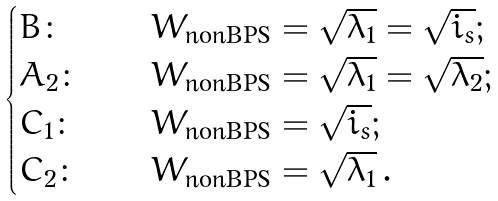<formula> <loc_0><loc_0><loc_500><loc_500>\begin{cases} B \colon \quad & W _ { \text {nonBPS} } = \sqrt { \lambda _ { 1 } } = \sqrt { i _ { s } } ; \\ A _ { 2 } \colon \quad & W _ { \text {nonBPS} } = \sqrt { \lambda _ { 1 } } = \sqrt { \lambda _ { 2 } } ; \\ C _ { 1 } \colon \quad & W _ { \text {nonBPS} } = \sqrt { i _ { s } } ; \\ C _ { 2 } \colon \quad & W _ { \text {nonBPS} } = \sqrt { \lambda _ { 1 } } \, . \end{cases}</formula> 